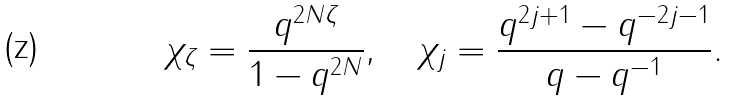Convert formula to latex. <formula><loc_0><loc_0><loc_500><loc_500>\chi _ { \zeta } = \frac { q ^ { 2 N \zeta } } { 1 - q ^ { 2 N } } , \quad \chi _ { j } = \frac { q ^ { 2 j + 1 } - q ^ { - 2 j - 1 } } { q - q ^ { - 1 } } .</formula> 